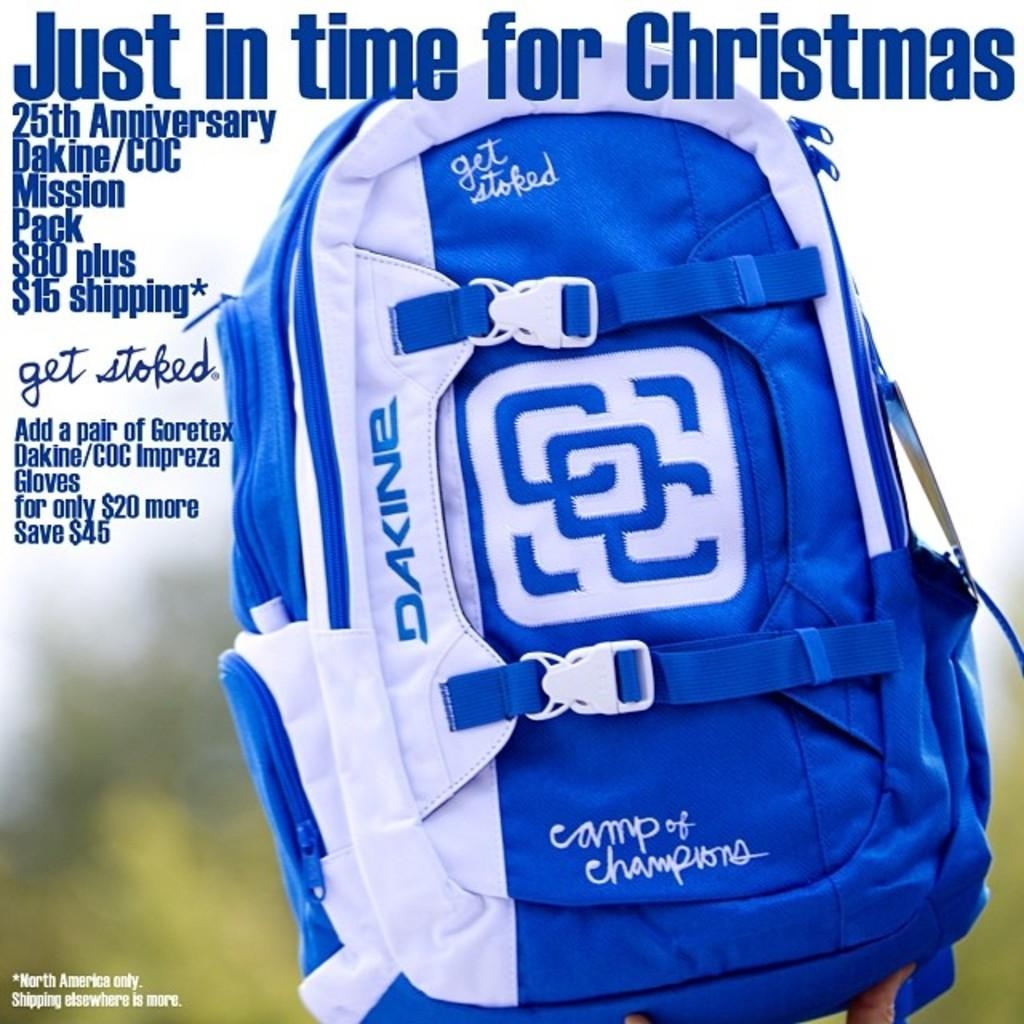What color is the bag that is visible in the image? The bag is blue and white. What is written on the bag? There is writing on the bag. Can you describe the background of the image? The background of the image is blurry. How many porters are carrying the bag in the image? There are no porters present in the image; it only shows a bag with writing on it. What type of light source is illuminating the bag in the image? There is no specific light source mentioned or visible in the image, as the background is blurry. 